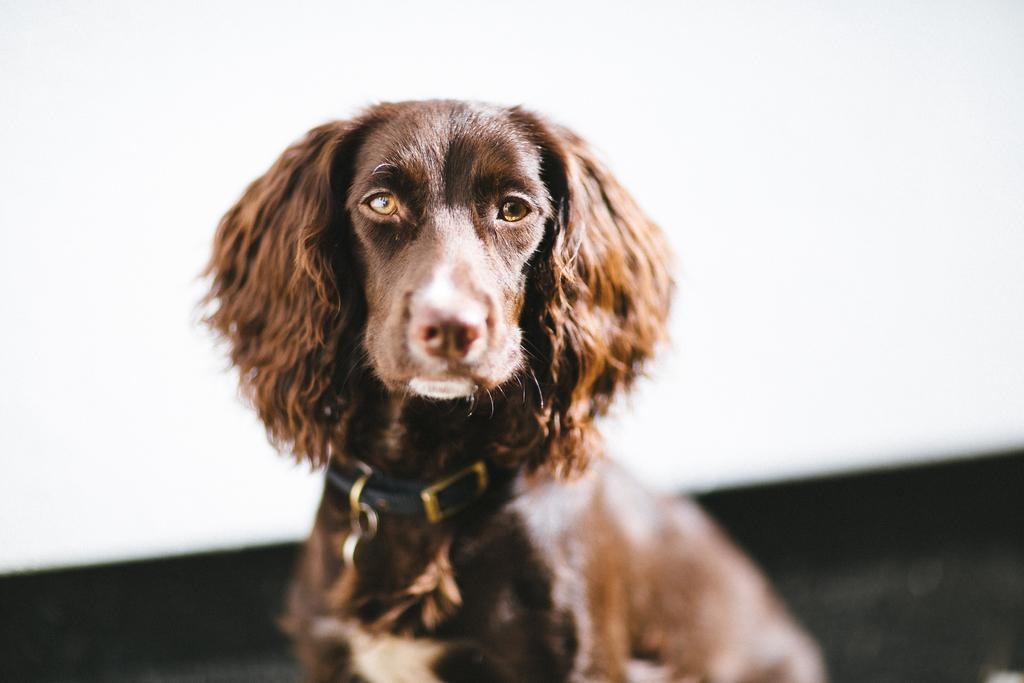What type of animal is in the image? There is a dog in the image. What color is the dog? The dog is black in color. Is there anything around the dog's neck? Yes, there is a belt around the dog's neck. What colors are present in the background of the image? The background of the image is white and black in color. Can you tell me how many giraffes are present in the image? There are no giraffes present in the image; it features a black dog with a belt around its neck and a white and black background. 